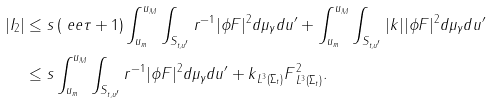Convert formula to latex. <formula><loc_0><loc_0><loc_500><loc_500>| I _ { 2 } | & \leq s \left ( \ e e \tau + 1 \right ) \int _ { u _ { m } } ^ { u _ { M } } \int _ { S _ { t , u ^ { \prime } } } r ^ { - 1 } | \phi F | ^ { 2 } d \mu _ { \gamma } d u ^ { \prime } + \int _ { u _ { m } } ^ { u _ { M } } \int _ { S _ { t , u ^ { \prime } } } | k | | \phi F | ^ { 2 } d \mu _ { \gamma } d u ^ { \prime } \\ & \leq s \int _ { u _ { m } } ^ { u _ { M } } \int _ { S _ { t , u ^ { \prime } } } r ^ { - 1 } | \phi F | ^ { 2 } d \mu _ { \gamma } d u ^ { \prime } + \| k \| _ { L ^ { 3 } ( \Sigma _ { t } ) } \| F \| _ { L ^ { 3 } ( \Sigma _ { t } ) } ^ { 2 } .</formula> 